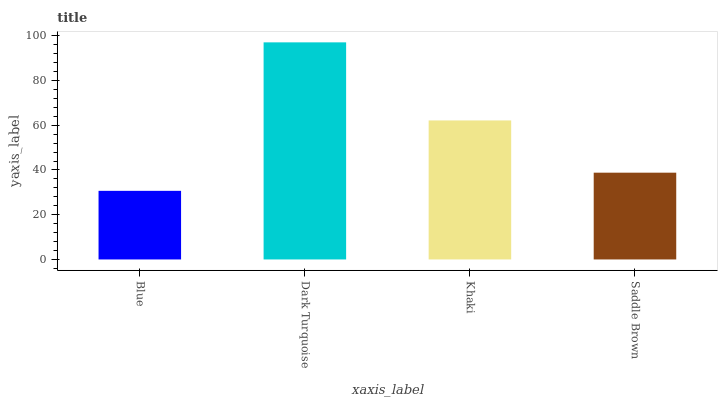Is Blue the minimum?
Answer yes or no. Yes. Is Dark Turquoise the maximum?
Answer yes or no. Yes. Is Khaki the minimum?
Answer yes or no. No. Is Khaki the maximum?
Answer yes or no. No. Is Dark Turquoise greater than Khaki?
Answer yes or no. Yes. Is Khaki less than Dark Turquoise?
Answer yes or no. Yes. Is Khaki greater than Dark Turquoise?
Answer yes or no. No. Is Dark Turquoise less than Khaki?
Answer yes or no. No. Is Khaki the high median?
Answer yes or no. Yes. Is Saddle Brown the low median?
Answer yes or no. Yes. Is Saddle Brown the high median?
Answer yes or no. No. Is Khaki the low median?
Answer yes or no. No. 